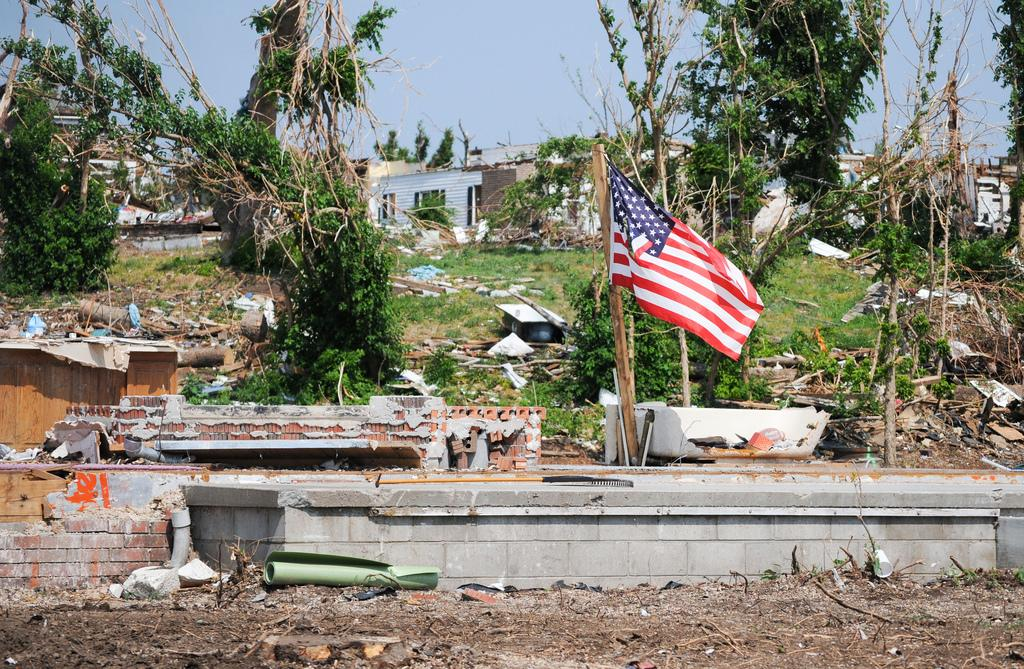What is the condition of the wall in the image? The wall in the image is destroyed. What can be seen flying in the image? There is a flag in the image. What type of natural scenery is visible in the background of the image? There are trees in the background of the image. What type of structures can be seen in the background of the image? There are houses in the background of the image. What is visible in the sky in the image? The sky is visible in the background of the image. What type of theory can be seen being tested in the image? There is no theory being tested in the image; it features a destroyed wall, a flag, trees, houses, and a visible sky. Can you see any dinosaurs in the image? There are no dinosaurs present in the image. 